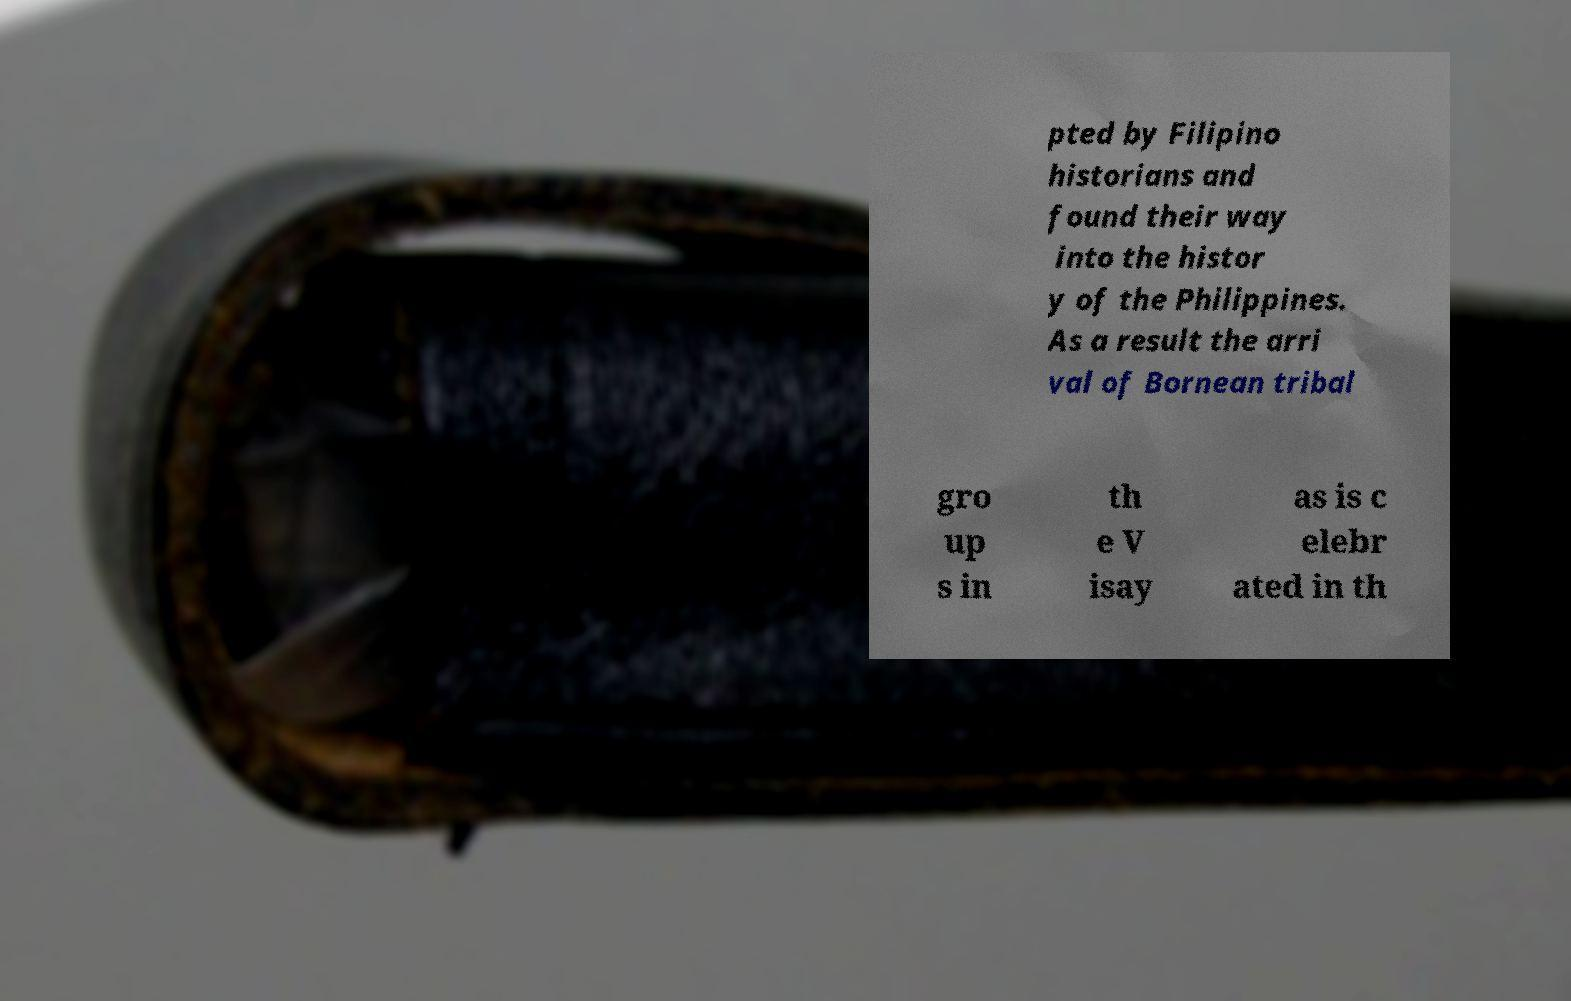There's text embedded in this image that I need extracted. Can you transcribe it verbatim? pted by Filipino historians and found their way into the histor y of the Philippines. As a result the arri val of Bornean tribal gro up s in th e V isay as is c elebr ated in th 